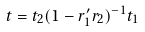<formula> <loc_0><loc_0><loc_500><loc_500>t = t _ { 2 } ( 1 - r _ { 1 } ^ { \prime } r _ { 2 } ) ^ { - 1 } t _ { 1 }</formula> 